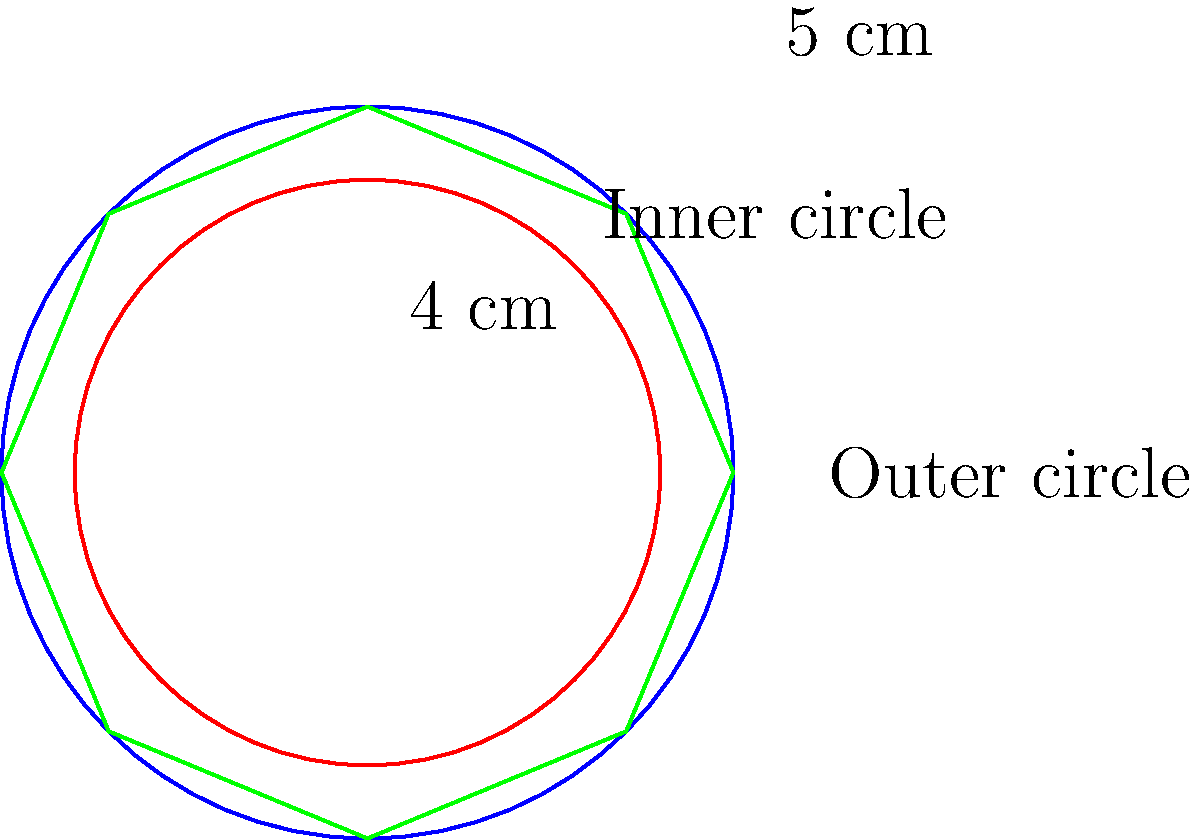A Tibetan mandala design is enclosed within a circular border. The outer circle has a radius of 5 cm, while the inner circle forming the main mandala area has a radius of 4 cm. Calculate the area of the decorative border region between the two circles, which often contains intricate Buddhist symbols and patterns. Round your answer to two decimal places. To find the area of the decorative border region, we need to:

1. Calculate the area of the outer circle:
   $A_{outer} = \pi r^2 = \pi (5\text{ cm})^2 = 25\pi\text{ cm}^2$

2. Calculate the area of the inner circle:
   $A_{inner} = \pi r^2 = \pi (4\text{ cm})^2 = 16\pi\text{ cm}^2$

3. Subtract the area of the inner circle from the outer circle:
   $A_{border} = A_{outer} - A_{inner} = 25\pi\text{ cm}^2 - 16\pi\text{ cm}^2 = 9\pi\text{ cm}^2$

4. Simplify and round to two decimal places:
   $9\pi\text{ cm}^2 \approx 28.27\text{ cm}^2$

Therefore, the area of the decorative border region is approximately 28.27 cm².
Answer: $28.27\text{ cm}^2$ 